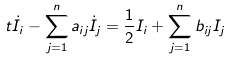<formula> <loc_0><loc_0><loc_500><loc_500>t \dot { I } _ { i } - \sum _ { j = 1 } ^ { n } a _ { i j } \dot { I } _ { j } = \frac { 1 } { 2 } I _ { i } + \sum _ { j = 1 } ^ { n } b _ { i j } I _ { j }</formula> 